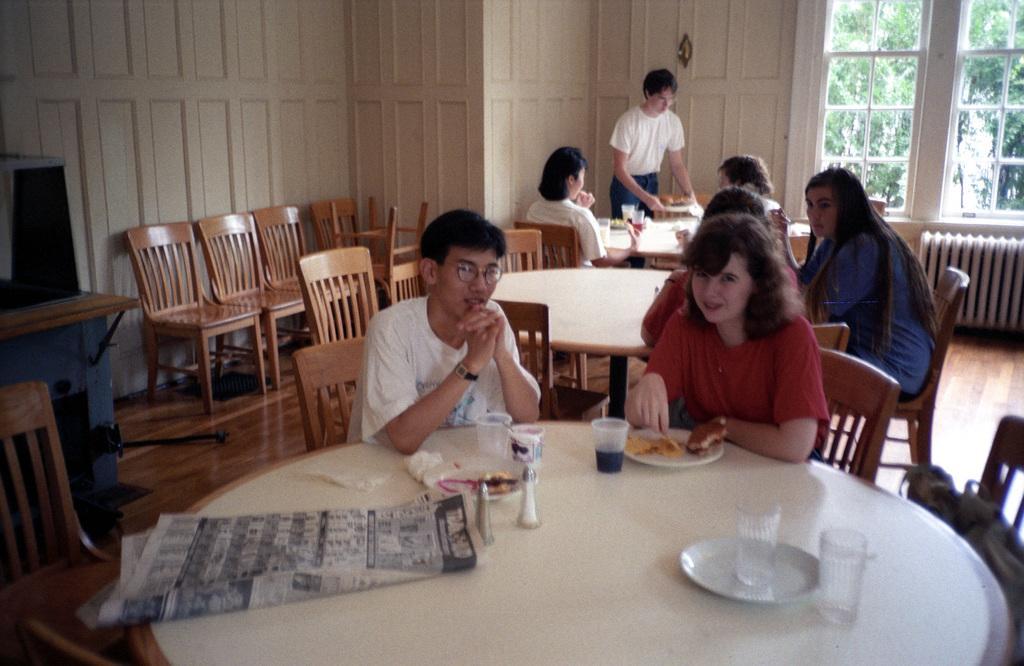Could you give a brief overview of what you see in this image? In this picture to the front of the table there is a lady with red t-shirt is sitting on the chair. In front of her there is a plate with food item on it. To the side the plate there is a glass with soft drink in it. And beside her there is a man with white t-shirt. In front of him there is a glass and a white color cup. On the table there is a plate to the right corner. On the plate there is a glass and beside the plate there is another glass. And to the left of the table there is a newspaper. In the background there are some people sitting. and a man with white t-shirt is sitting. To the right top corner there is a window. And to the left corner there are two chairs. 